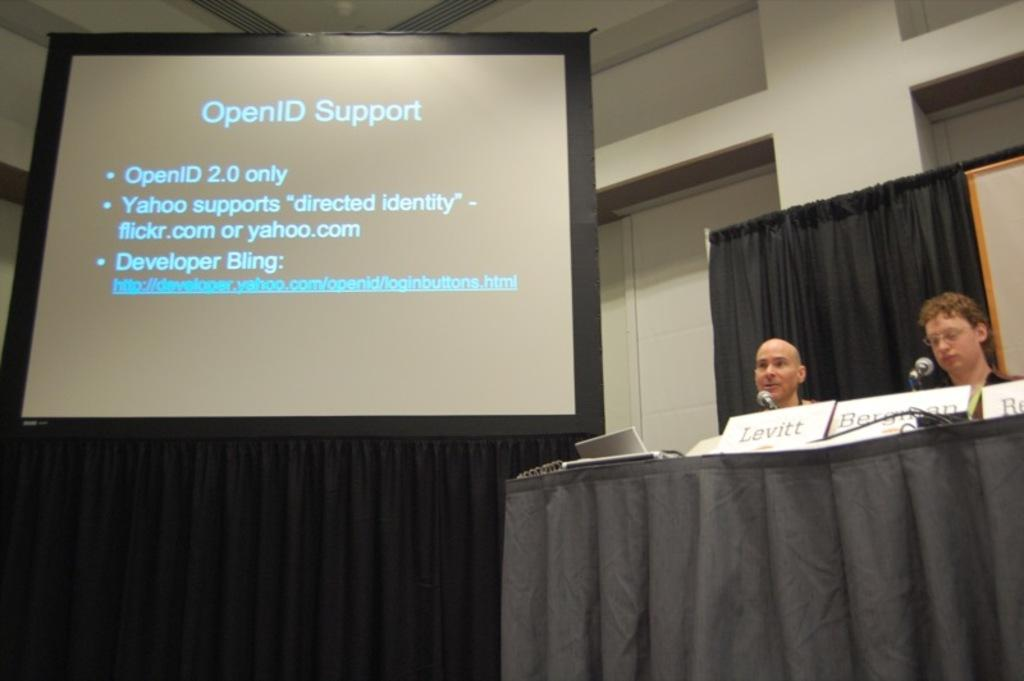What is the main object in the image? There is a screen present in the image. What type of window treatment can be seen in the image? Curtains are visible in the image. What is the background of the image made of? There is a wall in the image. What piece of furniture is in the image? A table is in the image. How many people are sitting in the image? Two people are sitting in the image. What is on the table with the people? There are mice and a laptop on the table. What type of bait is the goose using to catch the mice in the image? There is no goose present in the image, and therefore no bait or mice-catching activity can be observed. 